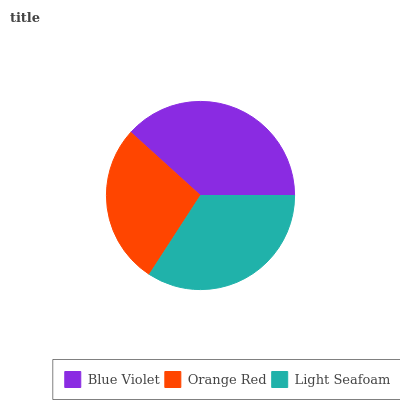Is Orange Red the minimum?
Answer yes or no. Yes. Is Blue Violet the maximum?
Answer yes or no. Yes. Is Light Seafoam the minimum?
Answer yes or no. No. Is Light Seafoam the maximum?
Answer yes or no. No. Is Light Seafoam greater than Orange Red?
Answer yes or no. Yes. Is Orange Red less than Light Seafoam?
Answer yes or no. Yes. Is Orange Red greater than Light Seafoam?
Answer yes or no. No. Is Light Seafoam less than Orange Red?
Answer yes or no. No. Is Light Seafoam the high median?
Answer yes or no. Yes. Is Light Seafoam the low median?
Answer yes or no. Yes. Is Blue Violet the high median?
Answer yes or no. No. Is Orange Red the low median?
Answer yes or no. No. 